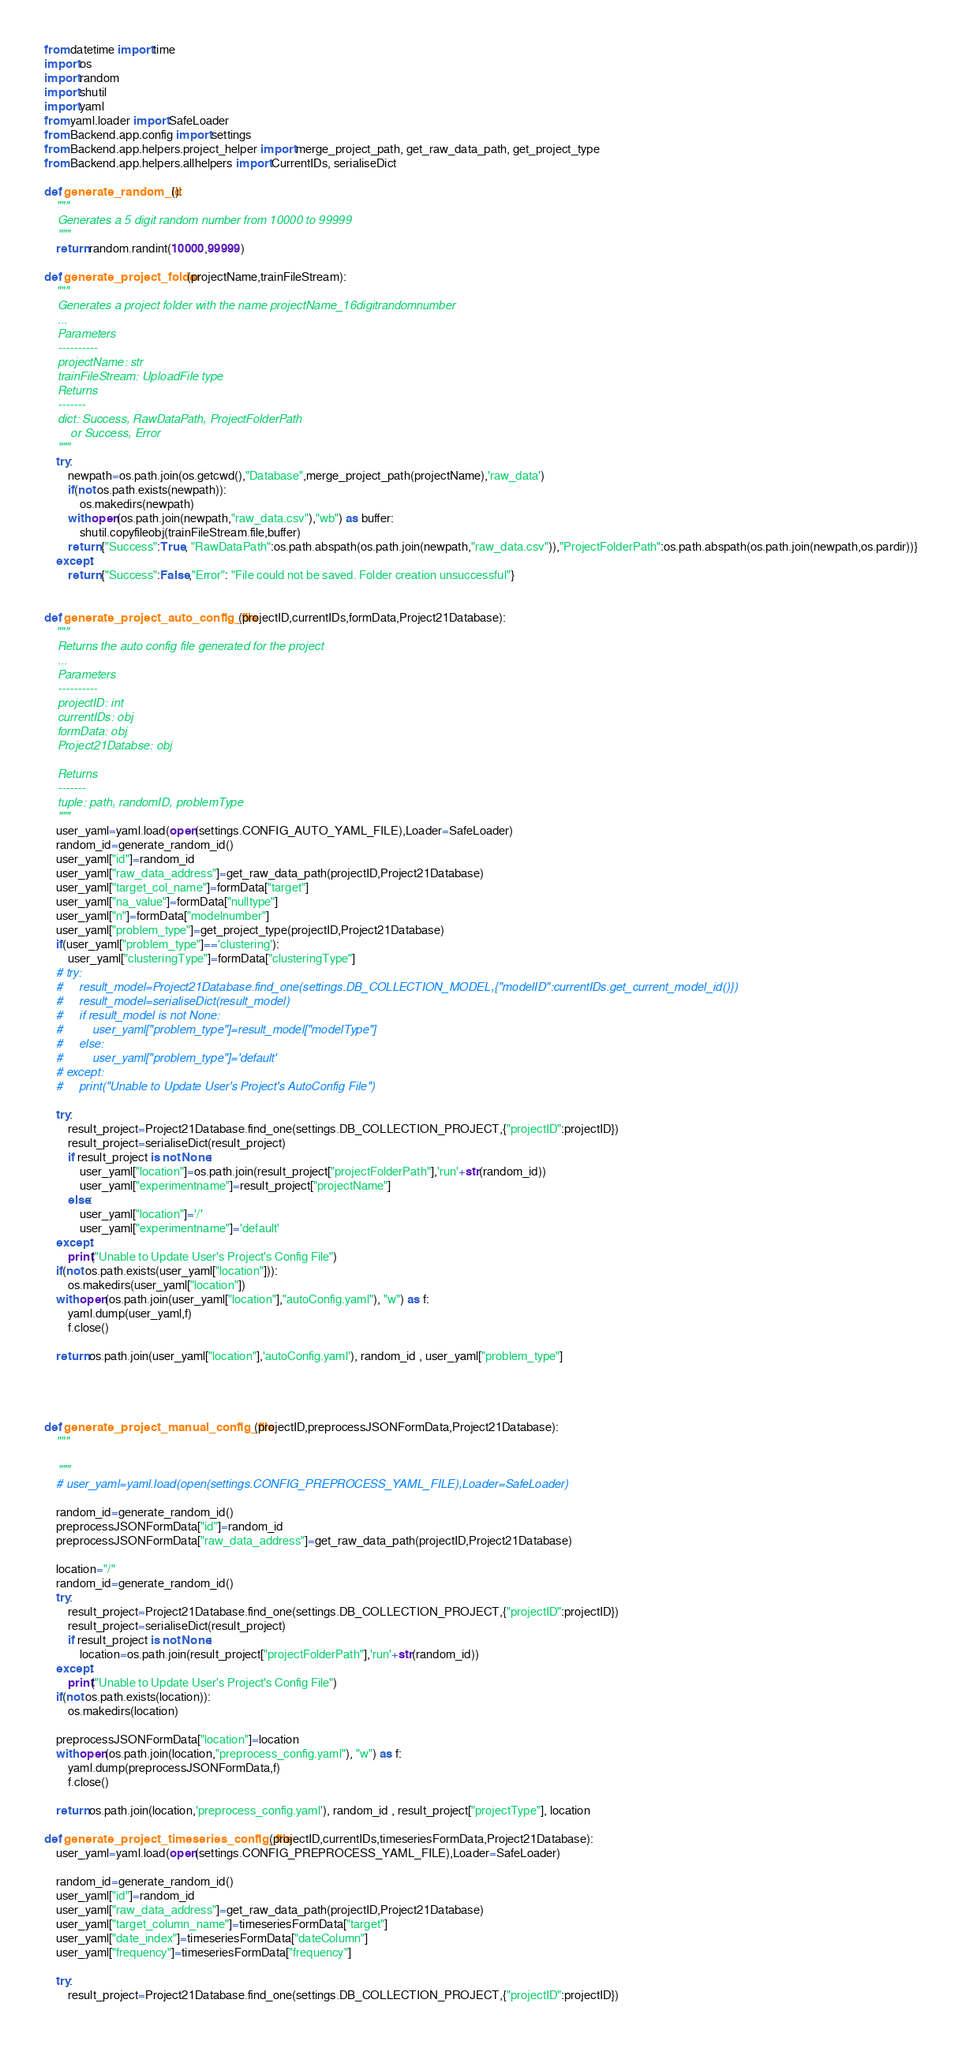<code> <loc_0><loc_0><loc_500><loc_500><_Python_>from datetime import time
import os
import random
import shutil
import yaml
from yaml.loader import SafeLoader
from Backend.app.config import settings
from Backend.app.helpers.project_helper import merge_project_path, get_raw_data_path, get_project_type
from Backend.app.helpers.allhelpers import CurrentIDs, serialiseDict

def generate_random_id():
    """
    Generates a 5 digit random number from 10000 to 99999
    """
    return random.randint(10000,99999)

def generate_project_folder(projectName,trainFileStream):
    """
    Generates a project folder with the name projectName_16digitrandomnumber
    ...
    Parameters
    ----------
    projectName: str
    trainFileStream: UploadFile type
    Returns
    -------
    dict: Success, RawDataPath, ProjectFolderPath
        or Success, Error
    """
    try:
        newpath=os.path.join(os.getcwd(),"Database",merge_project_path(projectName),'raw_data')
        if(not os.path.exists(newpath)):
            os.makedirs(newpath)
        with open(os.path.join(newpath,"raw_data.csv"),"wb") as buffer:
            shutil.copyfileobj(trainFileStream.file,buffer)
        return {"Success":True, "RawDataPath":os.path.abspath(os.path.join(newpath,"raw_data.csv")),"ProjectFolderPath":os.path.abspath(os.path.join(newpath,os.pardir))}
    except:
        return {"Success":False,"Error": "File could not be saved. Folder creation unsuccessful"}


def generate_project_auto_config_file(projectID,currentIDs,formData,Project21Database):
    """
    Returns the auto config file generated for the project
    ...
    Parameters
    ----------
    projectID: int
    currentIDs: obj
    formData: obj
    Project21Databse: obj
    
    Returns
    -------
    tuple: path, randomID, problemType
    """
    user_yaml=yaml.load(open(settings.CONFIG_AUTO_YAML_FILE),Loader=SafeLoader)
    random_id=generate_random_id()
    user_yaml["id"]=random_id
    user_yaml["raw_data_address"]=get_raw_data_path(projectID,Project21Database)
    user_yaml["target_col_name"]=formData["target"]
    user_yaml["na_value"]=formData["nulltype"]
    user_yaml["n"]=formData["modelnumber"]
    user_yaml["problem_type"]=get_project_type(projectID,Project21Database)
    if(user_yaml["problem_type"]=='clustering'):
        user_yaml["clusteringType"]=formData["clusteringType"]
    # try:
    #     result_model=Project21Database.find_one(settings.DB_COLLECTION_MODEL,{"modelID":currentIDs.get_current_model_id()})
    #     result_model=serialiseDict(result_model)
    #     if result_model is not None:
    #         user_yaml["problem_type"]=result_model["modelType"]
    #     else:
    #         user_yaml["problem_type"]='default'
    # except:
    #     print("Unable to Update User's Project's AutoConfig File")

    try:
        result_project=Project21Database.find_one(settings.DB_COLLECTION_PROJECT,{"projectID":projectID})
        result_project=serialiseDict(result_project)
        if result_project is not None:
            user_yaml["location"]=os.path.join(result_project["projectFolderPath"],'run'+str(random_id))
            user_yaml["experimentname"]=result_project["projectName"]
        else:
            user_yaml["location"]='/'
            user_yaml["experimentname"]='default'
    except:
        print("Unable to Update User's Project's Config File")
    if(not os.path.exists(user_yaml["location"])):
        os.makedirs(user_yaml["location"])
    with open(os.path.join(user_yaml["location"],"autoConfig.yaml"), "w") as f:
        yaml.dump(user_yaml,f)
        f.close()
    
    return os.path.join(user_yaml["location"],'autoConfig.yaml'), random_id , user_yaml["problem_type"]




def generate_project_manual_config_file(projectID,preprocessJSONFormData,Project21Database):
    """
    
    """
    # user_yaml=yaml.load(open(settings.CONFIG_PREPROCESS_YAML_FILE),Loader=SafeLoader)
    
    random_id=generate_random_id()
    preprocessJSONFormData["id"]=random_id
    preprocessJSONFormData["raw_data_address"]=get_raw_data_path(projectID,Project21Database)
    
    location="/"
    random_id=generate_random_id()
    try:
        result_project=Project21Database.find_one(settings.DB_COLLECTION_PROJECT,{"projectID":projectID})
        result_project=serialiseDict(result_project)
        if result_project is not None:
            location=os.path.join(result_project["projectFolderPath"],'run'+str(random_id))
    except:
        print("Unable to Update User's Project's Config File")
    if(not os.path.exists(location)):
        os.makedirs(location)

    preprocessJSONFormData["location"]=location
    with open(os.path.join(location,"preprocess_config.yaml"), "w") as f:
        yaml.dump(preprocessJSONFormData,f)
        f.close()
    
    return os.path.join(location,'preprocess_config.yaml'), random_id , result_project["projectType"], location

def generate_project_timeseries_config_file(projectID,currentIDs,timeseriesFormData,Project21Database):
    user_yaml=yaml.load(open(settings.CONFIG_PREPROCESS_YAML_FILE),Loader=SafeLoader)

    random_id=generate_random_id()
    user_yaml["id"]=random_id
    user_yaml["raw_data_address"]=get_raw_data_path(projectID,Project21Database)
    user_yaml["target_column_name"]=timeseriesFormData["target"]
    user_yaml["date_index"]=timeseriesFormData["dateColumn"]
    user_yaml["frequency"]=timeseriesFormData["frequency"]
    
    try:
        result_project=Project21Database.find_one(settings.DB_COLLECTION_PROJECT,{"projectID":projectID})</code> 